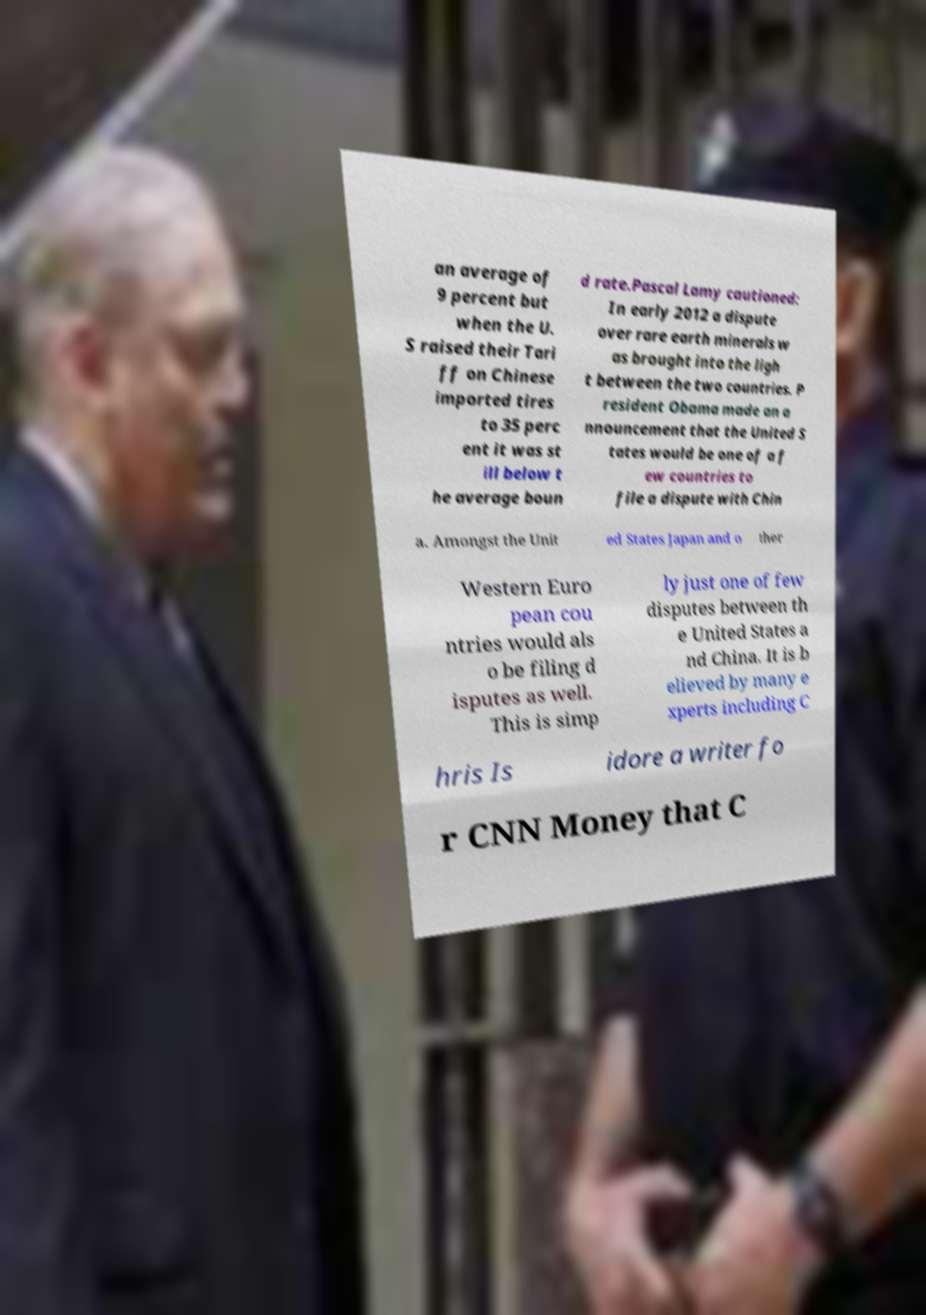For documentation purposes, I need the text within this image transcribed. Could you provide that? an average of 9 percent but when the U. S raised their Tari ff on Chinese imported tires to 35 perc ent it was st ill below t he average boun d rate.Pascal Lamy cautioned: In early 2012 a dispute over rare earth minerals w as brought into the ligh t between the two countries. P resident Obama made an a nnouncement that the United S tates would be one of a f ew countries to file a dispute with Chin a. Amongst the Unit ed States Japan and o ther Western Euro pean cou ntries would als o be filing d isputes as well. This is simp ly just one of few disputes between th e United States a nd China. It is b elieved by many e xperts including C hris Is idore a writer fo r CNN Money that C 